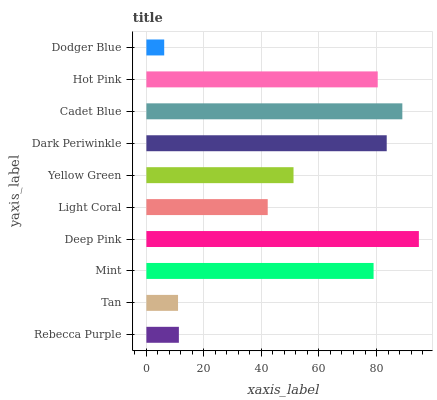Is Dodger Blue the minimum?
Answer yes or no. Yes. Is Deep Pink the maximum?
Answer yes or no. Yes. Is Tan the minimum?
Answer yes or no. No. Is Tan the maximum?
Answer yes or no. No. Is Rebecca Purple greater than Tan?
Answer yes or no. Yes. Is Tan less than Rebecca Purple?
Answer yes or no. Yes. Is Tan greater than Rebecca Purple?
Answer yes or no. No. Is Rebecca Purple less than Tan?
Answer yes or no. No. Is Mint the high median?
Answer yes or no. Yes. Is Yellow Green the low median?
Answer yes or no. Yes. Is Deep Pink the high median?
Answer yes or no. No. Is Light Coral the low median?
Answer yes or no. No. 